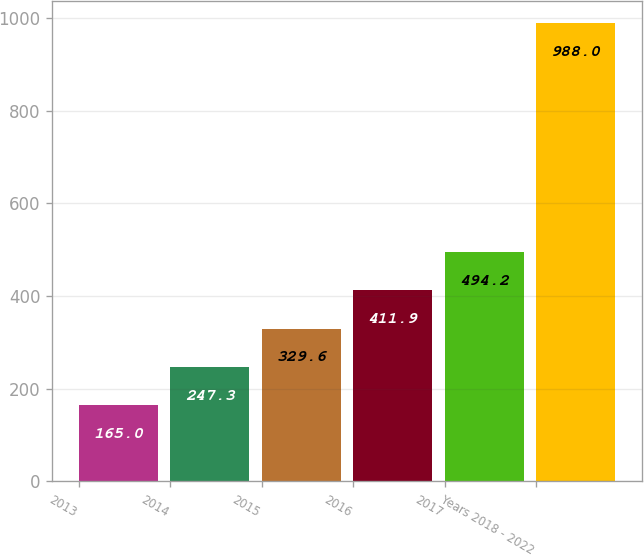Convert chart. <chart><loc_0><loc_0><loc_500><loc_500><bar_chart><fcel>2013<fcel>2014<fcel>2015<fcel>2016<fcel>2017<fcel>Years 2018 - 2022<nl><fcel>165<fcel>247.3<fcel>329.6<fcel>411.9<fcel>494.2<fcel>988<nl></chart> 